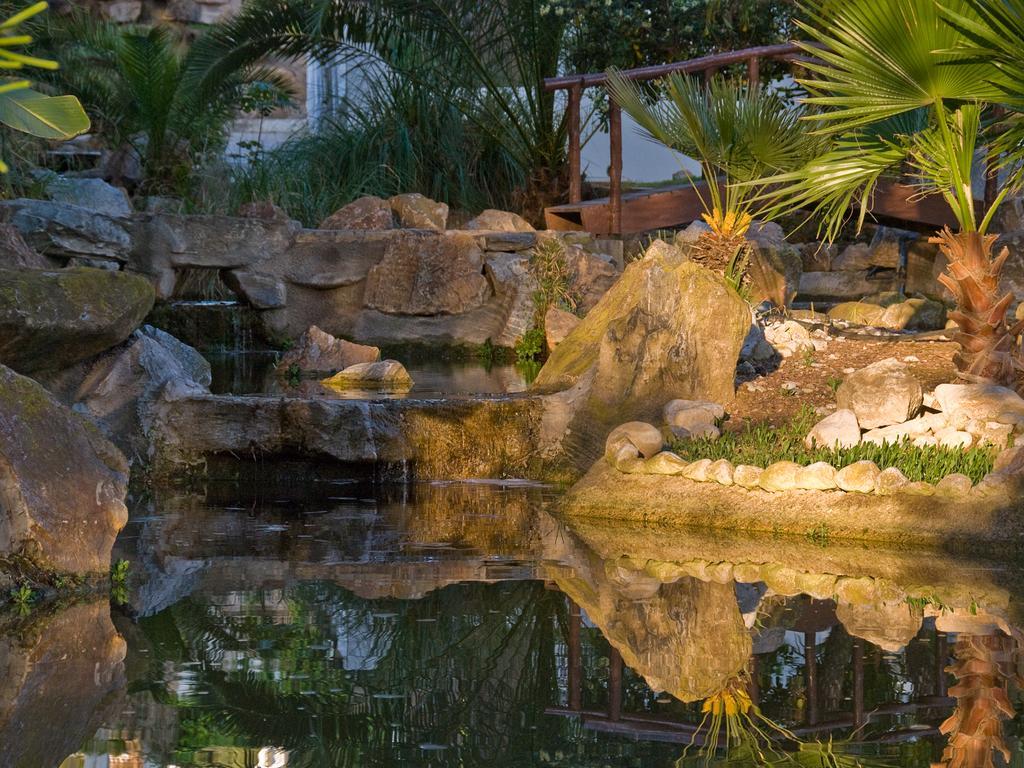Please provide a concise description of this image. In the picture I can see the water, rocks, trees, plants, wooden objects and some other objects on the ground. 